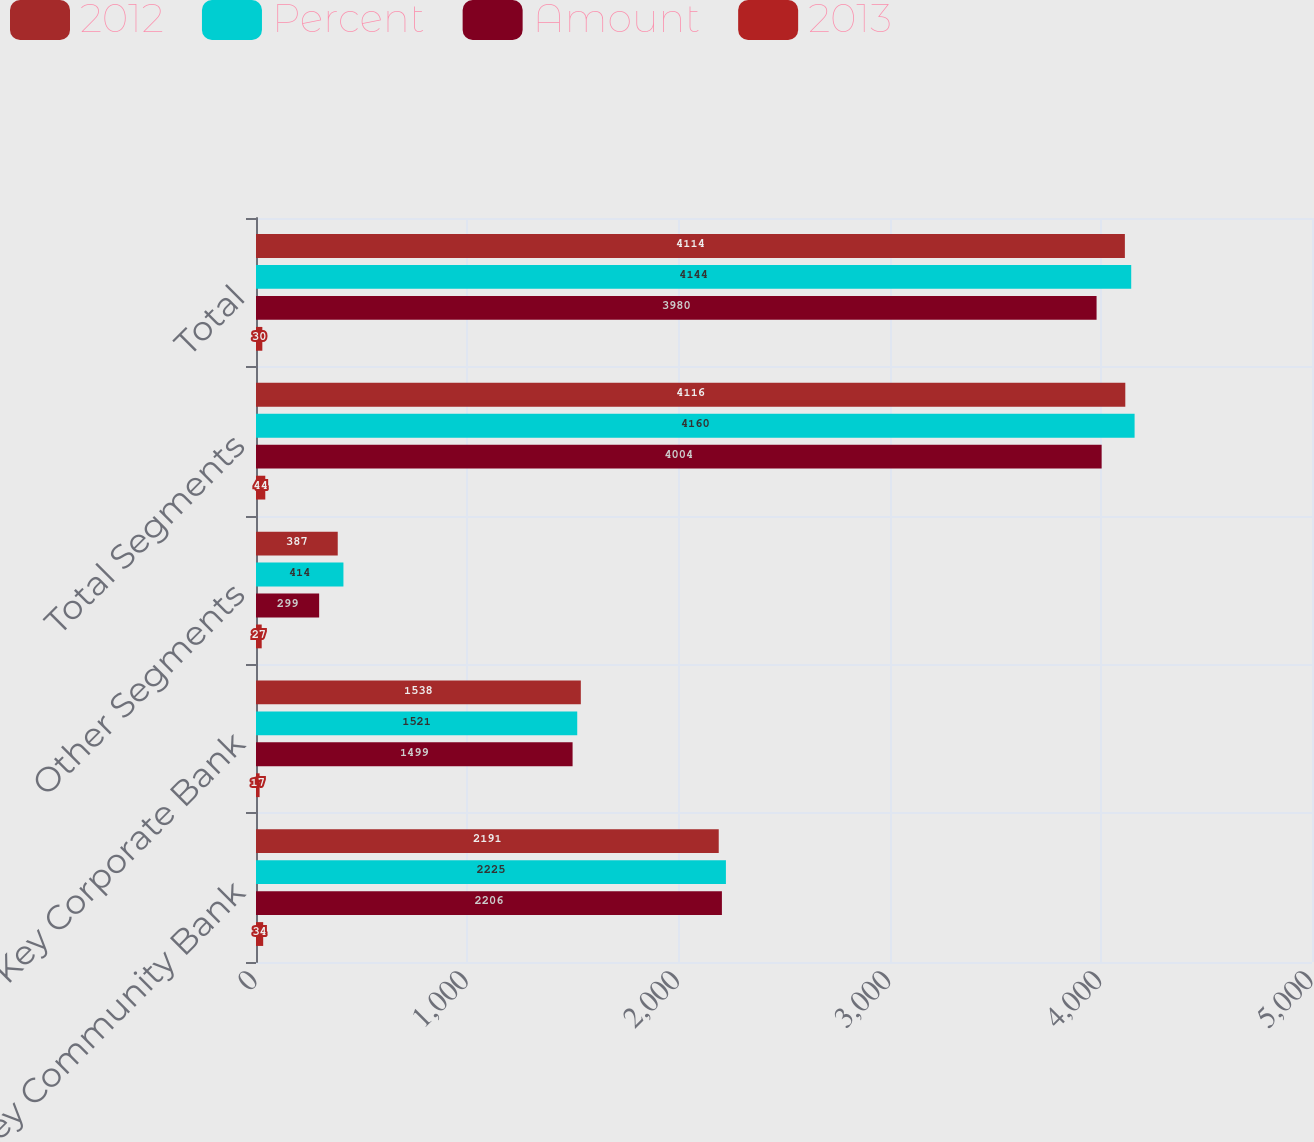<chart> <loc_0><loc_0><loc_500><loc_500><stacked_bar_chart><ecel><fcel>Key Community Bank<fcel>Key Corporate Bank<fcel>Other Segments<fcel>Total Segments<fcel>Total<nl><fcel>2012<fcel>2191<fcel>1538<fcel>387<fcel>4116<fcel>4114<nl><fcel>Percent<fcel>2225<fcel>1521<fcel>414<fcel>4160<fcel>4144<nl><fcel>Amount<fcel>2206<fcel>1499<fcel>299<fcel>4004<fcel>3980<nl><fcel>2013<fcel>34<fcel>17<fcel>27<fcel>44<fcel>30<nl></chart> 